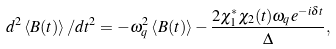<formula> <loc_0><loc_0><loc_500><loc_500>d ^ { 2 } \left \langle B ( t ) \right \rangle / d t ^ { 2 } = - \omega _ { q } ^ { 2 } \left \langle B ( t ) \right \rangle - \frac { 2 \chi _ { 1 } ^ { \ast } \chi _ { 2 } ( t ) \omega _ { q } e ^ { - i \delta t } } { \Delta } ,</formula> 